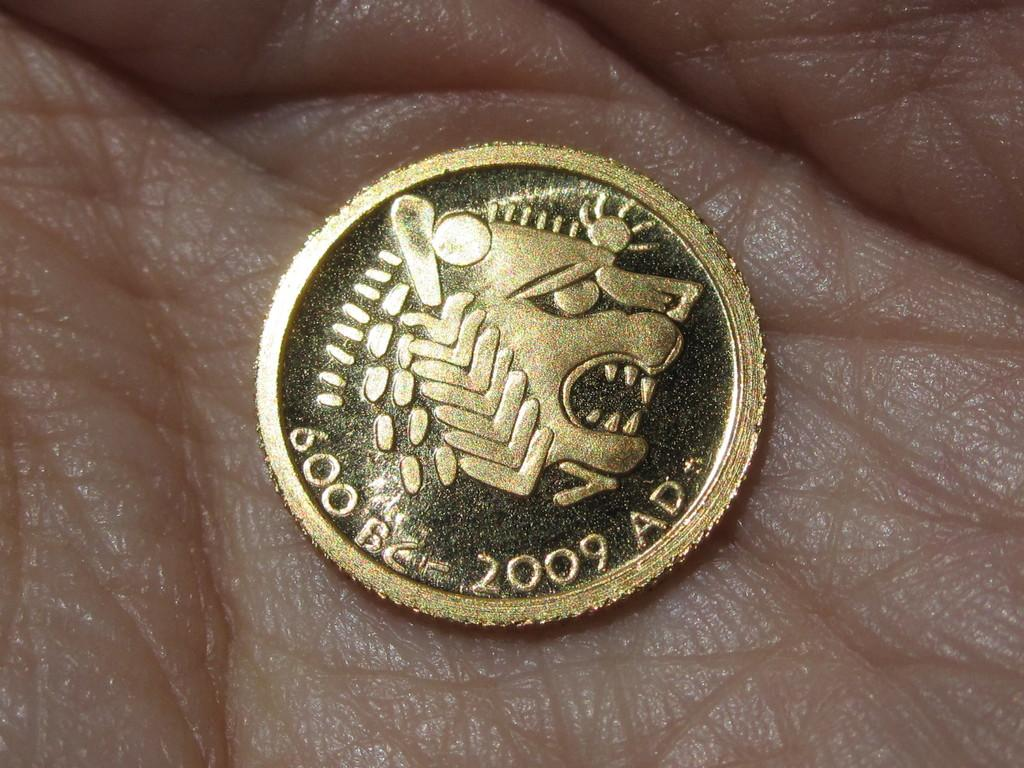<image>
Provide a brief description of the given image. A gold coin that says 600 BC-2009 AD sits in the palm of a hand 